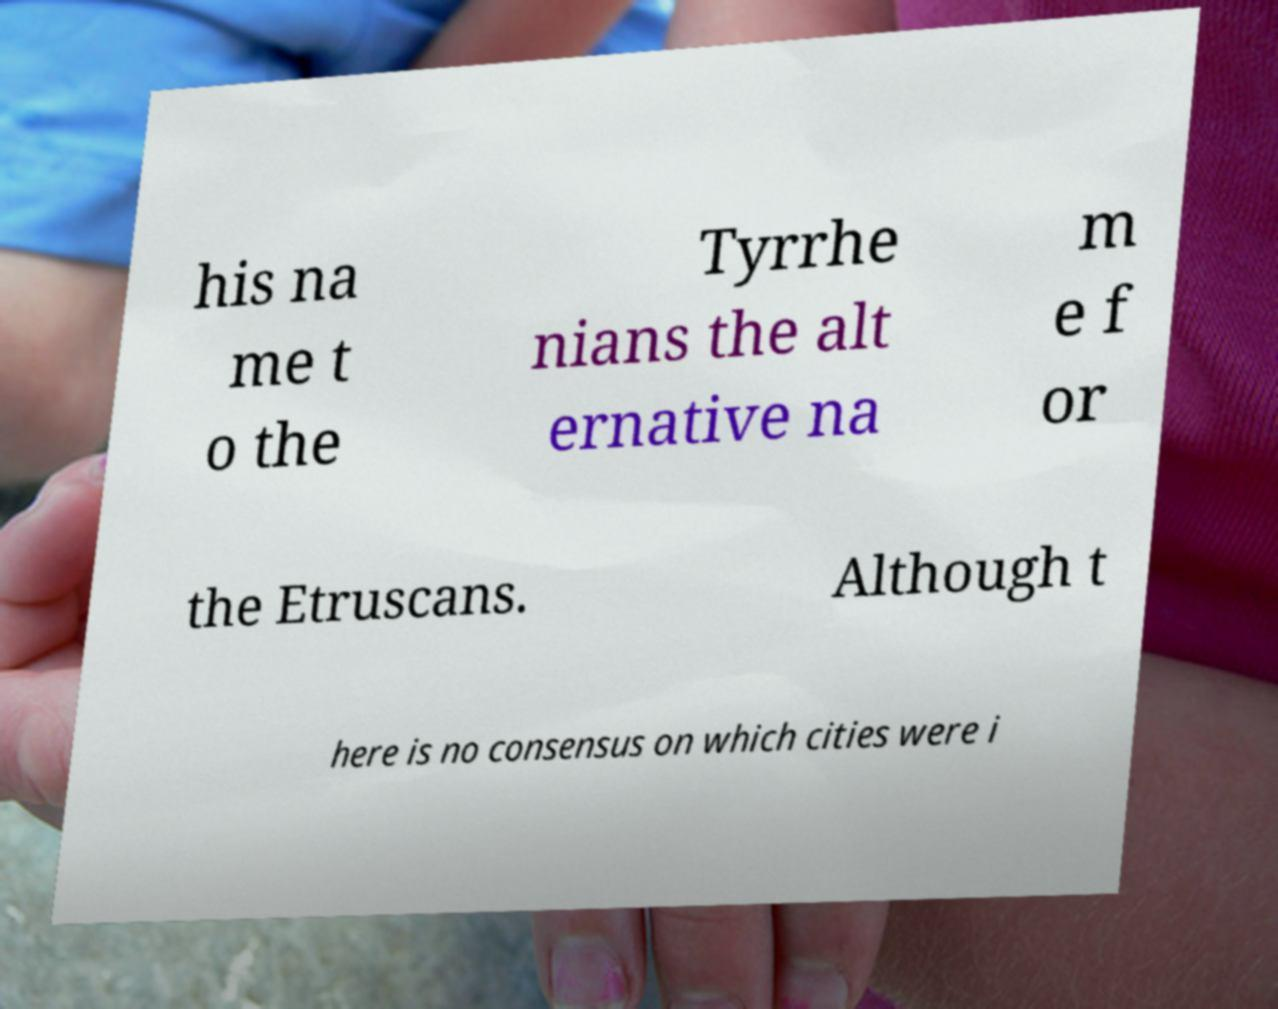Please identify and transcribe the text found in this image. his na me t o the Tyrrhe nians the alt ernative na m e f or the Etruscans. Although t here is no consensus on which cities were i 